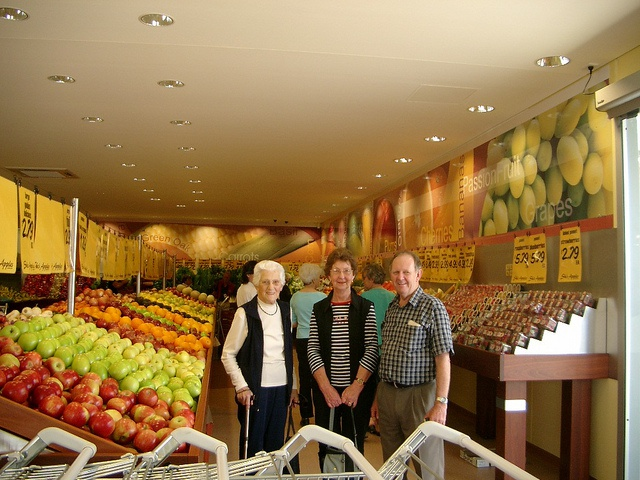Describe the objects in this image and their specific colors. I can see people in gray, black, and brown tones, people in gray and black tones, people in gray, black, beige, and tan tones, apple in gray, brown, red, and maroon tones, and apple in gray, olive, khaki, and gold tones in this image. 